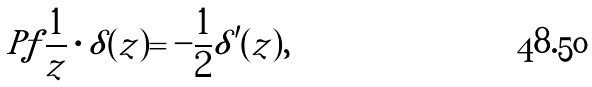Convert formula to latex. <formula><loc_0><loc_0><loc_500><loc_500>P f \frac { 1 } { z } \cdot \delta ( z ) = - \frac { 1 } { 2 } \delta ^ { \prime } ( z ) ,</formula> 